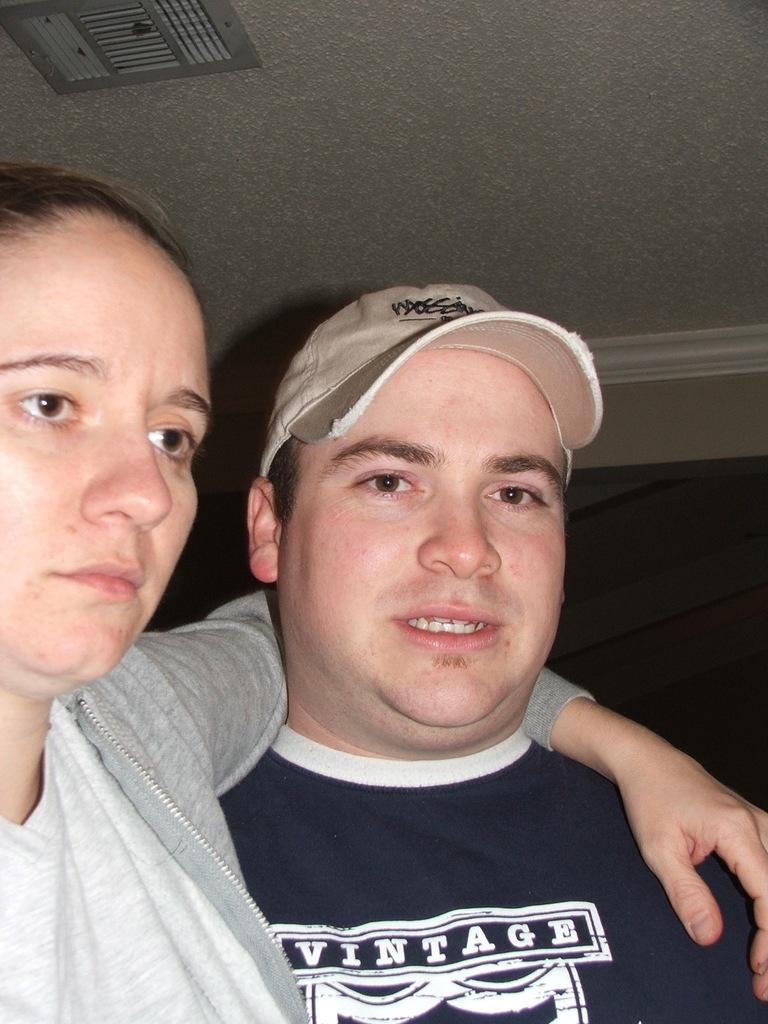<image>
Describe the image concisely. A male in the hat is wearing a shirt with Vintage on it 